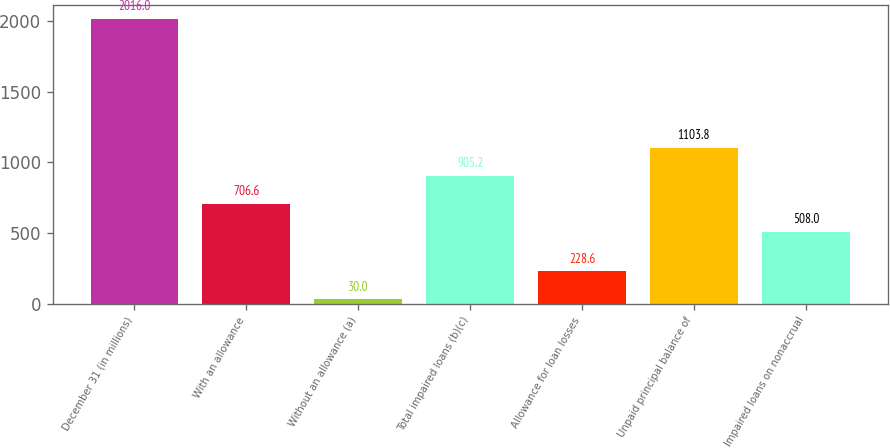<chart> <loc_0><loc_0><loc_500><loc_500><bar_chart><fcel>December 31 (in millions)<fcel>With an allowance<fcel>Without an allowance (a)<fcel>Total impaired loans (b)(c)<fcel>Allowance for loan losses<fcel>Unpaid principal balance of<fcel>Impaired loans on nonaccrual<nl><fcel>2016<fcel>706.6<fcel>30<fcel>905.2<fcel>228.6<fcel>1103.8<fcel>508<nl></chart> 